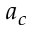Convert formula to latex. <formula><loc_0><loc_0><loc_500><loc_500>a _ { c }</formula> 